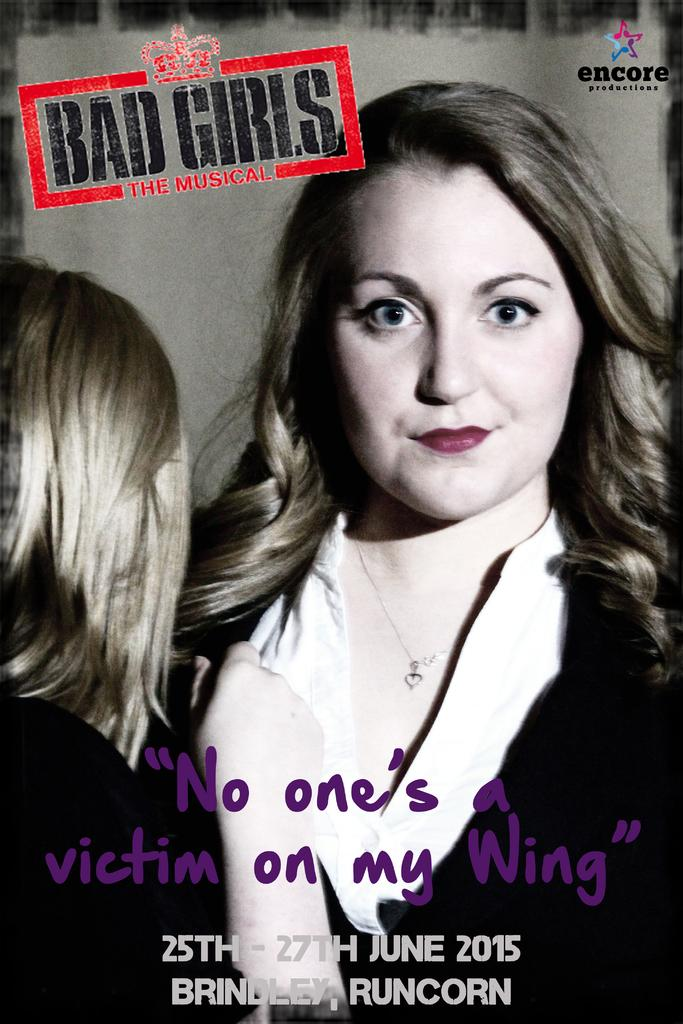What is on the wall in the image? There is a poster on the wall in the image. What is depicted on the poster? The poster contains a picture of a girl. Are there any additional elements on the poster besides the picture? Yes, there is a logo, text, and a watermark on the poster. What type of marble can be seen in the vein of the girl's hand in the image? There is no marble or vein visible in the image, and the girl's hand is not mentioned in the provided facts. 